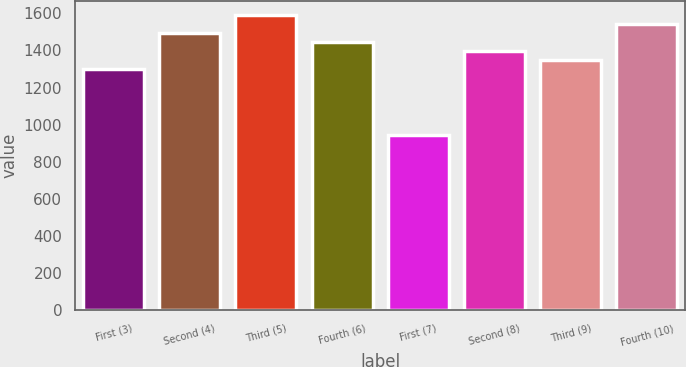Convert chart. <chart><loc_0><loc_0><loc_500><loc_500><bar_chart><fcel>First (3)<fcel>Second (4)<fcel>Third (5)<fcel>Fourth (6)<fcel>First (7)<fcel>Second (8)<fcel>Third (9)<fcel>Fourth (10)<nl><fcel>1301<fcel>1493<fcel>1589<fcel>1445<fcel>944<fcel>1397<fcel>1349<fcel>1541<nl></chart> 